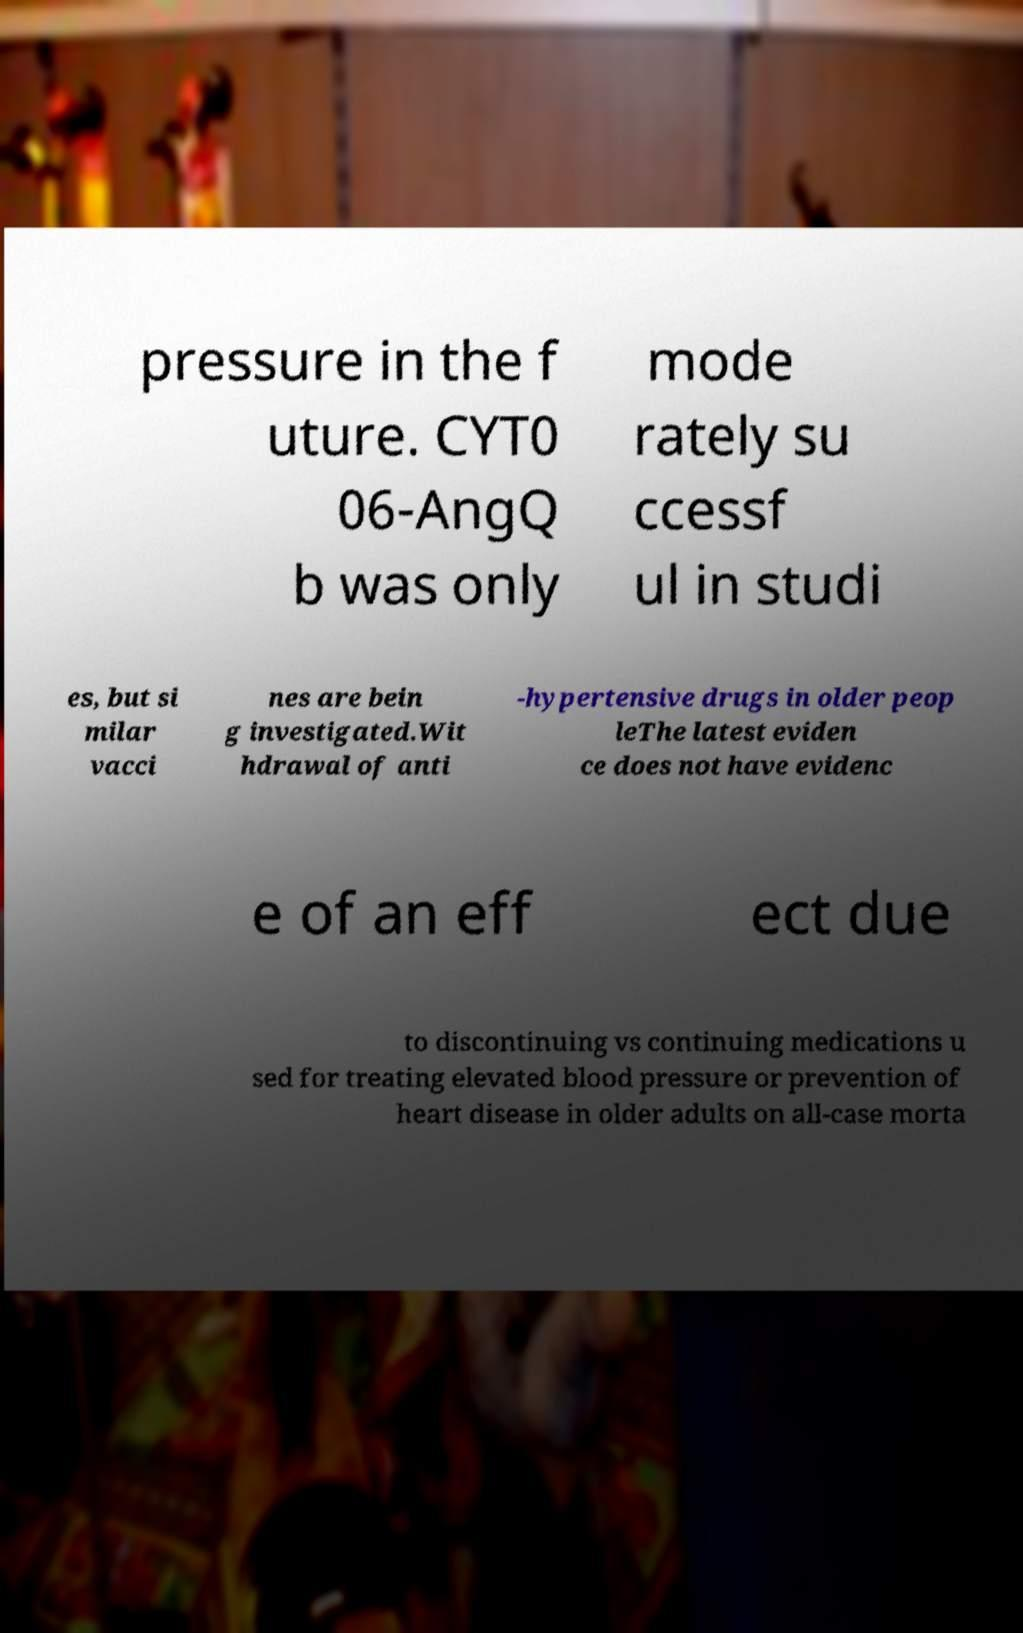What messages or text are displayed in this image? I need them in a readable, typed format. pressure in the f uture. CYT0 06-AngQ b was only mode rately su ccessf ul in studi es, but si milar vacci nes are bein g investigated.Wit hdrawal of anti -hypertensive drugs in older peop leThe latest eviden ce does not have evidenc e of an eff ect due to discontinuing vs continuing medications u sed for treating elevated blood pressure or prevention of heart disease in older adults on all-case morta 